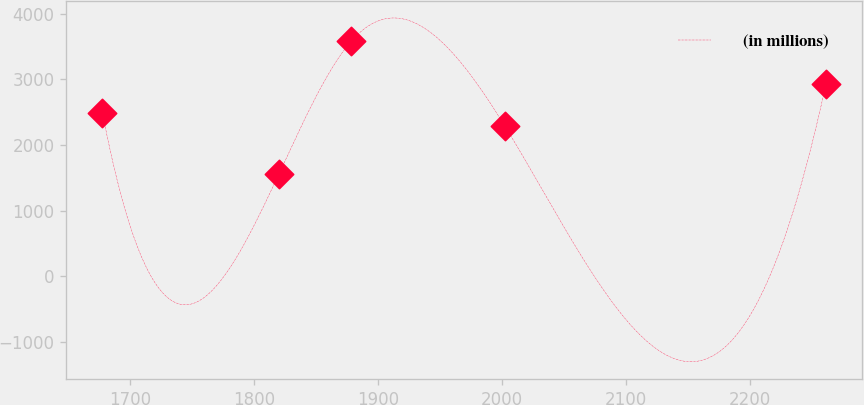Convert chart. <chart><loc_0><loc_0><loc_500><loc_500><line_chart><ecel><fcel>(in millions)<nl><fcel>1677.52<fcel>2488.53<nl><fcel>1820.07<fcel>1563.12<nl><fcel>1878.45<fcel>3585.48<nl><fcel>2002.32<fcel>2286.29<nl><fcel>2261.36<fcel>2926.15<nl></chart> 